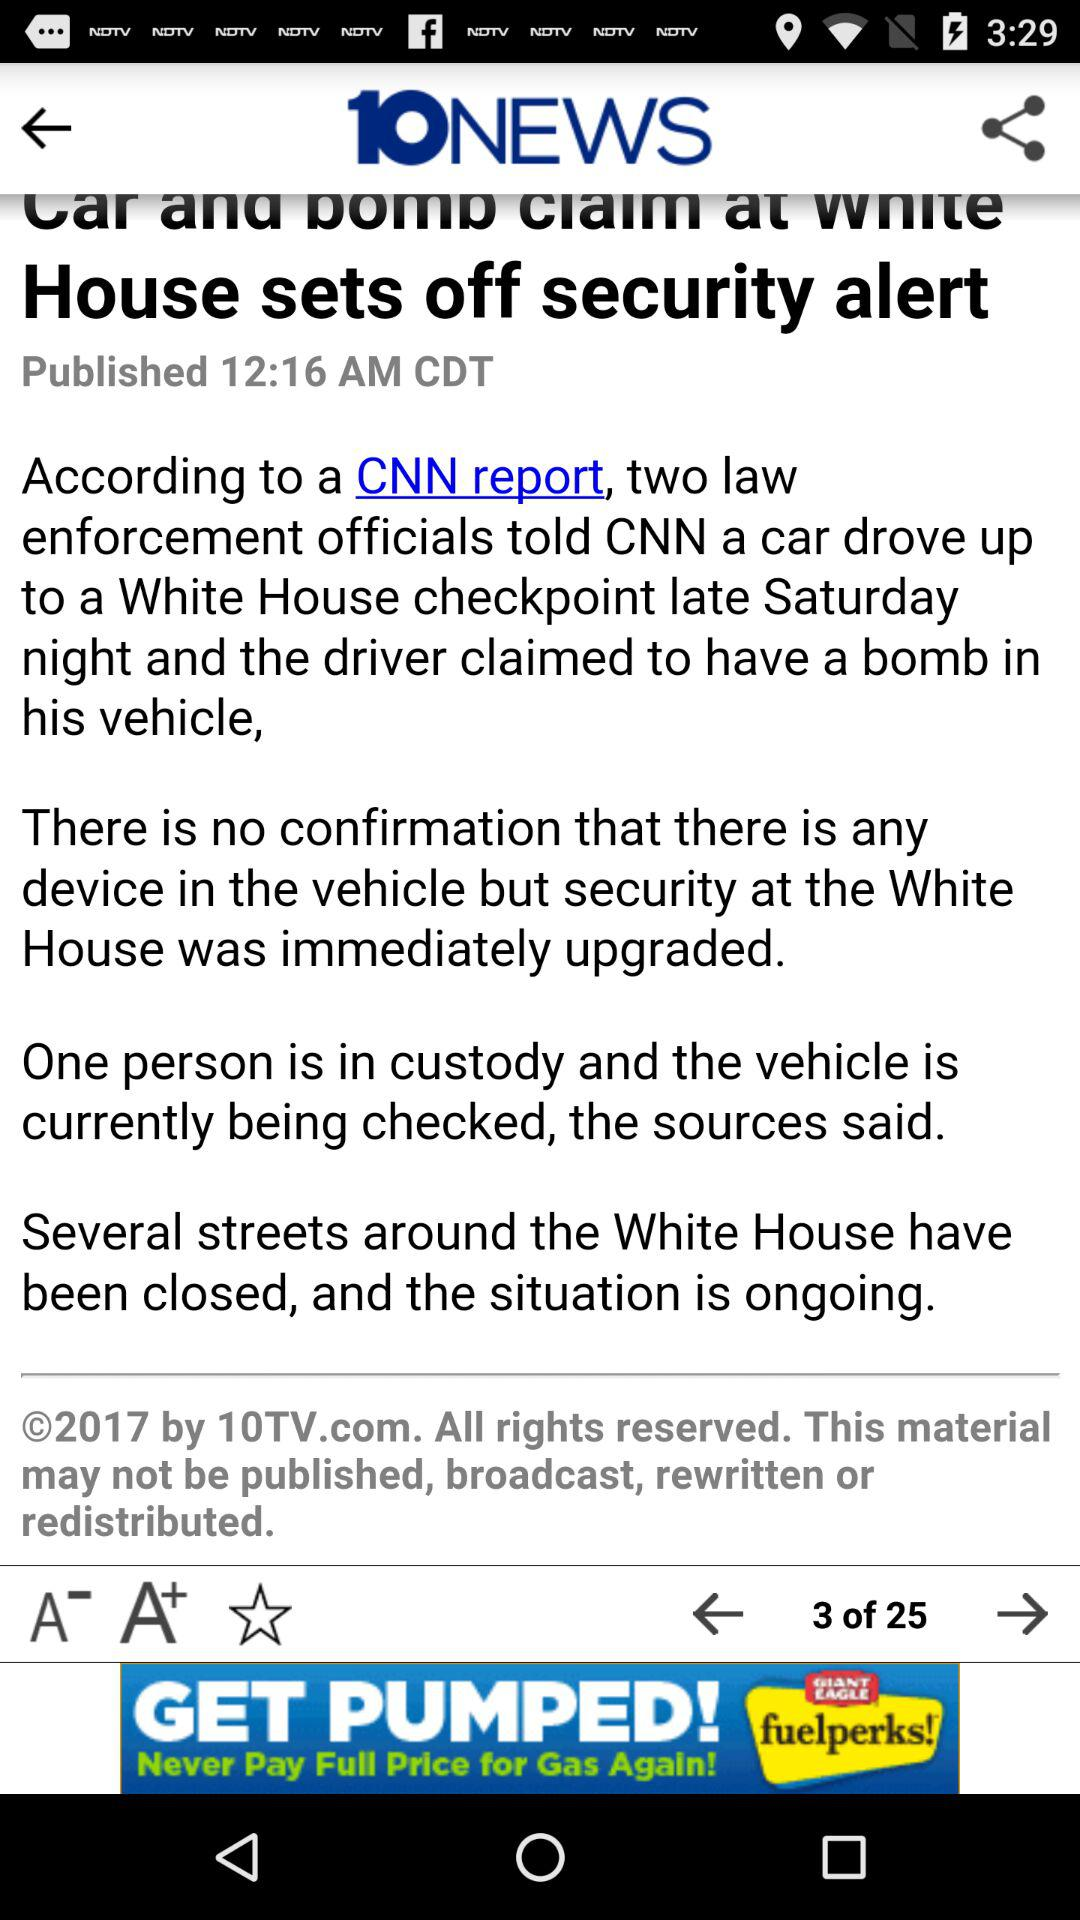What is the total number of pages of content? The total number of pages is 25. 